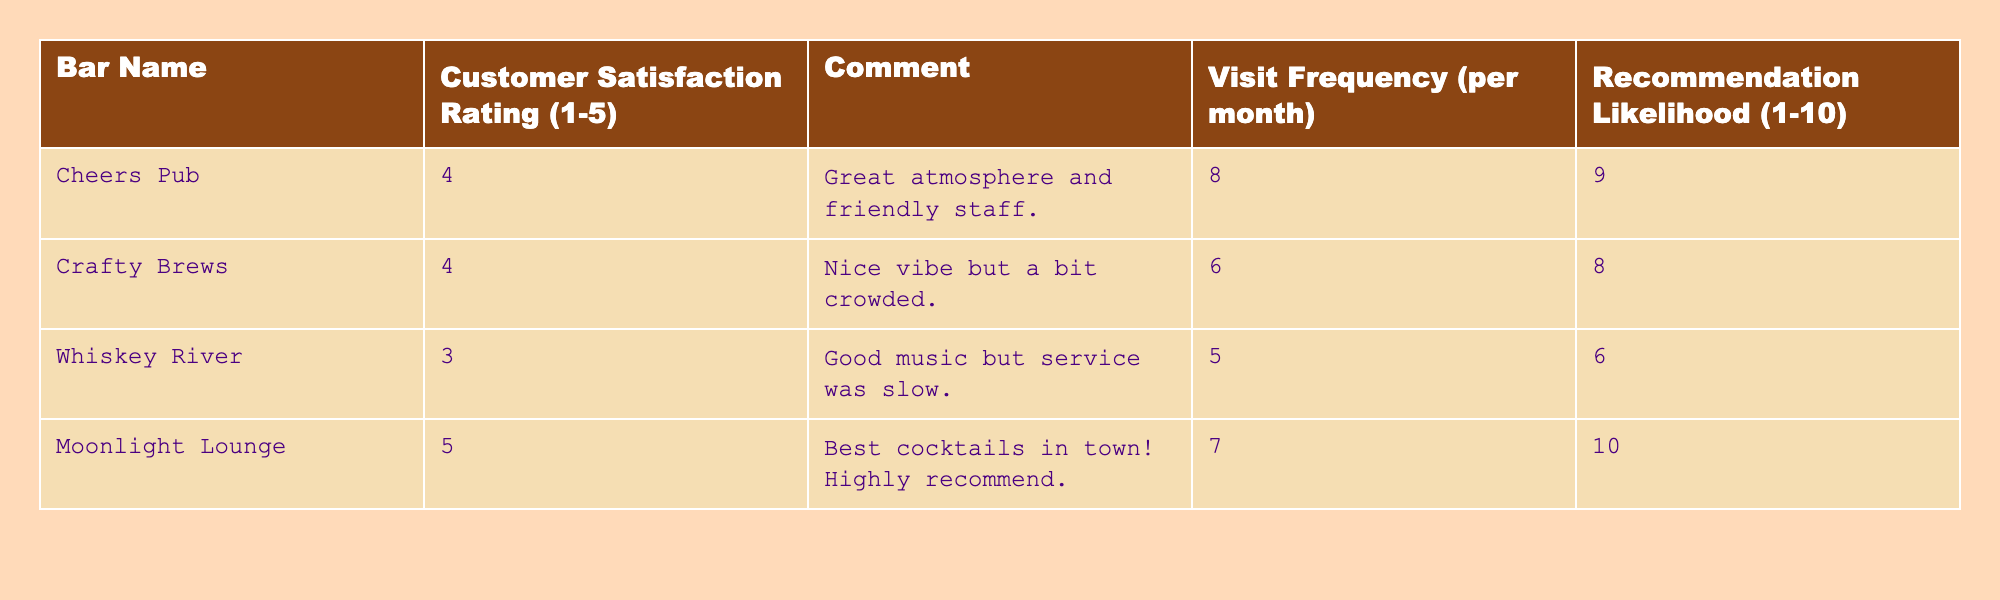What is the customer satisfaction rating for Moonlight Lounge? The table shows that the customer satisfaction rating for Moonlight Lounge is listed as 5.
Answer: 5 Which bar has the highest recommendation likelihood? By looking at the "Recommendation Likelihood" column, Moonlight Lounge has the highest score of 10.
Answer: Moonlight Lounge What is the average customer satisfaction rating of all bars? To calculate the average, we sum the ratings (4 + 4 + 3 + 5) = 16 and divide by the number of bars (4), giving us an average rating of 4.
Answer: 4 Did Whiskey River receive a customer satisfaction rating of 4 or higher? The customer satisfaction rating for Whiskey River is 3, which is below 4. Therefore, the answer is no.
Answer: No Which bar has the lowest visit frequency per month? Checking the "Visit Frequency" column, Whiskey River has the lowest visit frequency at 5 per month.
Answer: Whiskey River What is the difference in recommendation likelihood between Cheers Pub and Crafty Brews? The recommendation likelihood for Cheers Pub is 9, and for Crafty Brews, it is 8. The difference is 9 - 8 = 1.
Answer: 1 How many bars have customer satisfaction ratings of 4 or higher? The bars with ratings of 4 or higher are Cheers Pub, Crafty Brews, and Moonlight Lounge, totaling 3 bars.
Answer: 3 If a customer prefers bars with a comment about atmosphere, which bars would they likely choose? The comments indicate that Cheers Pub has a "great atmosphere" and Crafty Brews has a "nice vibe." So, customers may choose either Cheers Pub or Crafty Brews.
Answer: Cheers Pub and Crafty Brews Which bar received the lowest satisfaction rating, and what was the comment associated with it? Whiskey River received the lowest satisfaction rating of 3, with the comment "Good music but service was slow."
Answer: Whiskey River; "Good music but service was slow." If a customer visited each bar once per month, how many total visits would they make to the five bars combined in a month? Adding the visit frequencies: 8 + 6 + 5 + 7 = 26 visits in total for the four bars. Note that only four bars are listed.
Answer: 26 